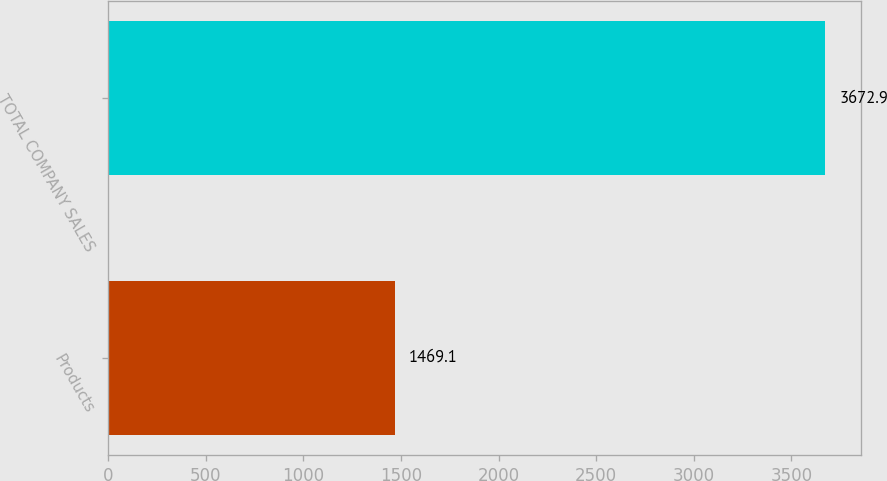<chart> <loc_0><loc_0><loc_500><loc_500><bar_chart><fcel>Products<fcel>TOTAL COMPANY SALES<nl><fcel>1469.1<fcel>3672.9<nl></chart> 